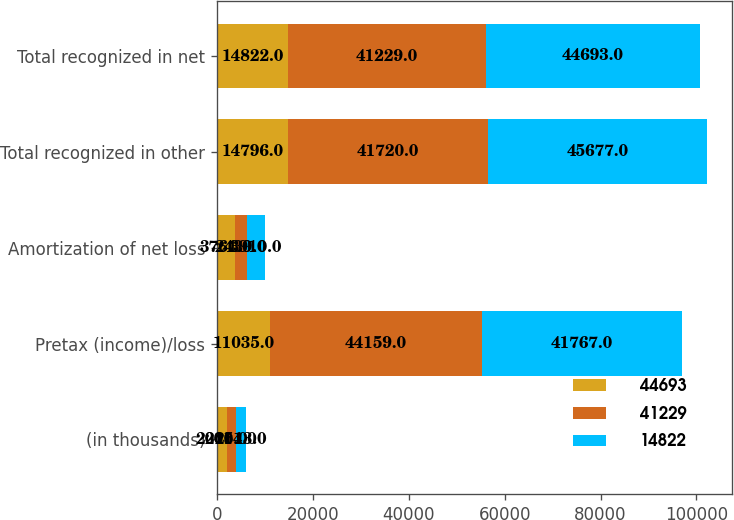Convert chart. <chart><loc_0><loc_0><loc_500><loc_500><stacked_bar_chart><ecel><fcel>(in thousands)<fcel>Pretax (income)/loss<fcel>Amortization of net loss<fcel>Total recognized in other<fcel>Total recognized in net<nl><fcel>44693<fcel>2015<fcel>11035<fcel>3761<fcel>14796<fcel>14822<nl><fcel>41229<fcel>2014<fcel>44159<fcel>2439<fcel>41720<fcel>41229<nl><fcel>14822<fcel>2013<fcel>41767<fcel>3910<fcel>45677<fcel>44693<nl></chart> 